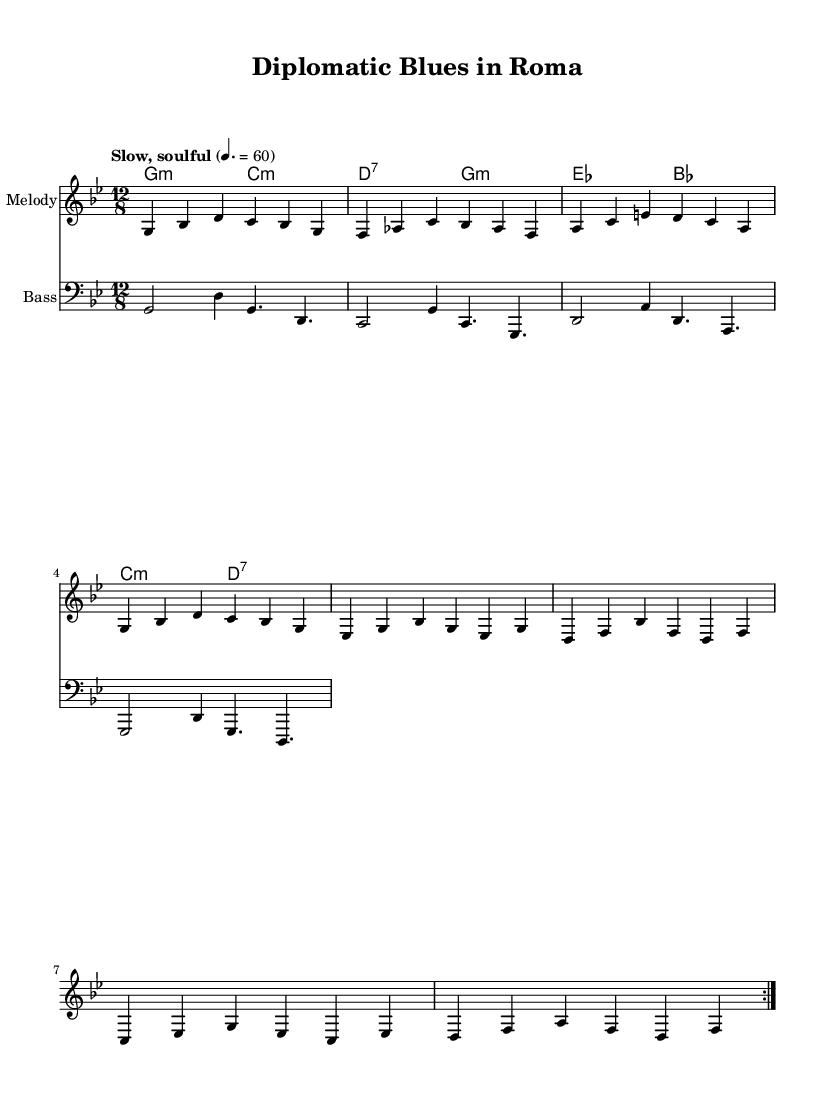What is the key signature of this music? The key signature is G minor, as indicated by the two flats (B♭ and E♭) in the key signature area on the staff.
Answer: G minor What is the time signature of this music? The time signature is 12/8, which indicates a compound meter with four beats per measure, and each beat can be subdivided into three eighth notes. This is visible in the upper left corner of the sheet music.
Answer: 12/8 What is the tempo marking for this piece? The tempo marking is "Slow, soulful," indicating a leisurely pace for the performance. It is stated above the staff to guide the musician.
Answer: Slow, soulful How many bars are repeated in the melody? The melody section has two bars repeated, as indicated by the repeat sign at the beginning of the relevant section of the melody.
Answer: 2 What type of chord is used in the first measure of the harmonies? The first measure of the harmonies indicates a G minor chord, evident from the chord notation provided in that measure.
Answer: G minor What lyrical theme is presented in the verse? The lyrical theme reflects the challenges and realities of diplomatic life in Rome, emphasizing the struggles faced despite the historical beauty of the city. This is inferred from the lyrics themselves which speak about "diplomatic life" and "Roman blues."
Answer: Diplomatic struggles What type of musical structure is primarily used in this piece? This piece primarily employs a 12-bar blues structure, typical of blues music. The harmonic pattern and repetition of phrases are characteristics of this structure as seen throughout the musical layout.
Answer: 12-bar blues 